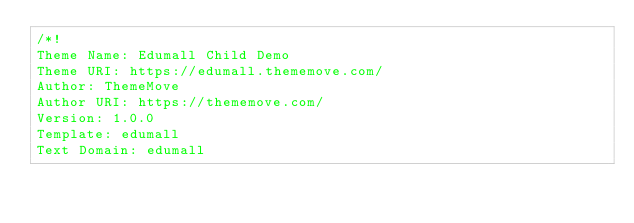<code> <loc_0><loc_0><loc_500><loc_500><_CSS_>/*!
Theme Name: Edumall Child Demo
Theme URI: https://edumall.thememove.com/
Author: ThemeMove
Author URI: https://thememove.com/
Version: 1.0.0
Template: edumall
Text Domain: edumall</code> 